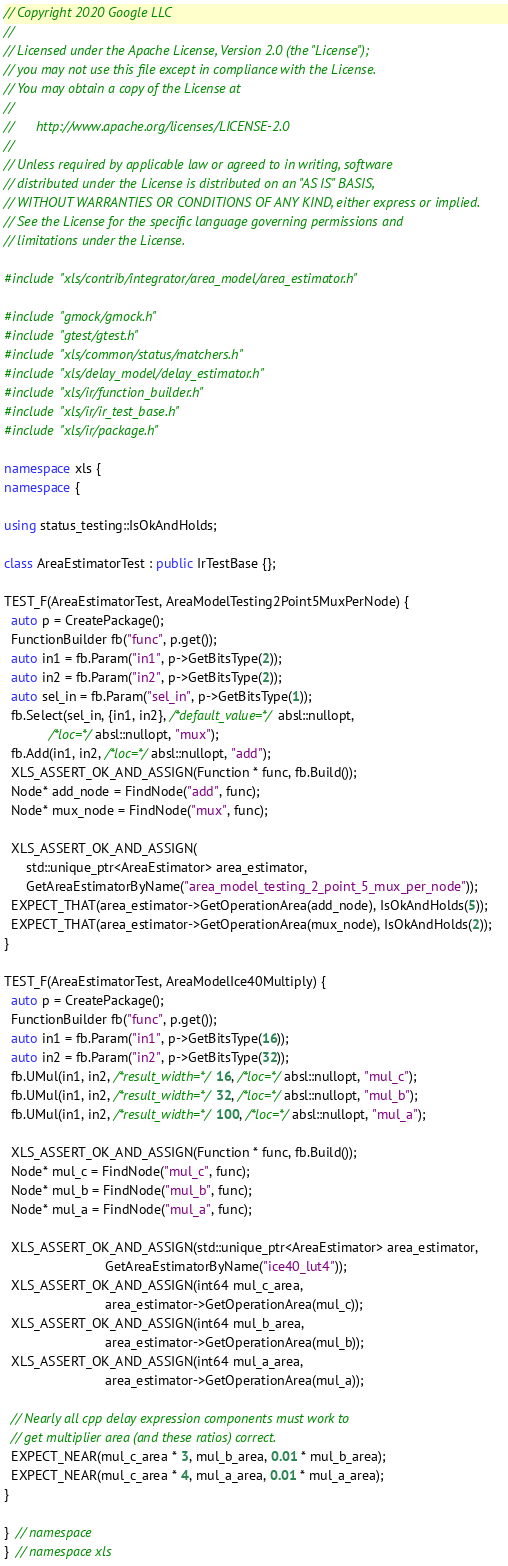<code> <loc_0><loc_0><loc_500><loc_500><_C++_>// Copyright 2020 Google LLC
//
// Licensed under the Apache License, Version 2.0 (the "License");
// you may not use this file except in compliance with the License.
// You may obtain a copy of the License at
//
//      http://www.apache.org/licenses/LICENSE-2.0
//
// Unless required by applicable law or agreed to in writing, software
// distributed under the License is distributed on an "AS IS" BASIS,
// WITHOUT WARRANTIES OR CONDITIONS OF ANY KIND, either express or implied.
// See the License for the specific language governing permissions and
// limitations under the License.

#include "xls/contrib/integrator/area_model/area_estimator.h"

#include "gmock/gmock.h"
#include "gtest/gtest.h"
#include "xls/common/status/matchers.h"
#include "xls/delay_model/delay_estimator.h"
#include "xls/ir/function_builder.h"
#include "xls/ir/ir_test_base.h"
#include "xls/ir/package.h"

namespace xls {
namespace {

using status_testing::IsOkAndHolds;

class AreaEstimatorTest : public IrTestBase {};

TEST_F(AreaEstimatorTest, AreaModelTesting2Point5MuxPerNode) {
  auto p = CreatePackage();
  FunctionBuilder fb("func", p.get());
  auto in1 = fb.Param("in1", p->GetBitsType(2));
  auto in2 = fb.Param("in2", p->GetBitsType(2));
  auto sel_in = fb.Param("sel_in", p->GetBitsType(1));
  fb.Select(sel_in, {in1, in2}, /*default_value=*/absl::nullopt,
            /*loc=*/absl::nullopt, "mux");
  fb.Add(in1, in2, /*loc=*/absl::nullopt, "add");
  XLS_ASSERT_OK_AND_ASSIGN(Function * func, fb.Build());
  Node* add_node = FindNode("add", func);
  Node* mux_node = FindNode("mux", func);

  XLS_ASSERT_OK_AND_ASSIGN(
      std::unique_ptr<AreaEstimator> area_estimator,
      GetAreaEstimatorByName("area_model_testing_2_point_5_mux_per_node"));
  EXPECT_THAT(area_estimator->GetOperationArea(add_node), IsOkAndHolds(5));
  EXPECT_THAT(area_estimator->GetOperationArea(mux_node), IsOkAndHolds(2));
}

TEST_F(AreaEstimatorTest, AreaModelIce40Multiply) {
  auto p = CreatePackage();
  FunctionBuilder fb("func", p.get());
  auto in1 = fb.Param("in1", p->GetBitsType(16));
  auto in2 = fb.Param("in2", p->GetBitsType(32));
  fb.UMul(in1, in2, /*result_width=*/16, /*loc=*/absl::nullopt, "mul_c");
  fb.UMul(in1, in2, /*result_width=*/32, /*loc=*/absl::nullopt, "mul_b");
  fb.UMul(in1, in2, /*result_width=*/100, /*loc=*/absl::nullopt, "mul_a");

  XLS_ASSERT_OK_AND_ASSIGN(Function * func, fb.Build());
  Node* mul_c = FindNode("mul_c", func);
  Node* mul_b = FindNode("mul_b", func);
  Node* mul_a = FindNode("mul_a", func);

  XLS_ASSERT_OK_AND_ASSIGN(std::unique_ptr<AreaEstimator> area_estimator,
                           GetAreaEstimatorByName("ice40_lut4"));
  XLS_ASSERT_OK_AND_ASSIGN(int64 mul_c_area,
                           area_estimator->GetOperationArea(mul_c));
  XLS_ASSERT_OK_AND_ASSIGN(int64 mul_b_area,
                           area_estimator->GetOperationArea(mul_b));
  XLS_ASSERT_OK_AND_ASSIGN(int64 mul_a_area,
                           area_estimator->GetOperationArea(mul_a));

  // Nearly all cpp delay expression components must work to
  // get multiplier area (and these ratios) correct.
  EXPECT_NEAR(mul_c_area * 3, mul_b_area, 0.01 * mul_b_area);
  EXPECT_NEAR(mul_c_area * 4, mul_a_area, 0.01 * mul_a_area);
}

}  // namespace
}  // namespace xls
</code> 